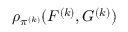<formula> <loc_0><loc_0><loc_500><loc_500>\rho _ { \pi ^ { ( k ) } } ( F ^ { ( k ) } , G ^ { ( k ) } )</formula> 